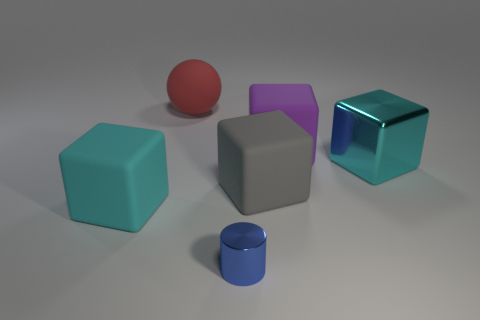Subtract all big cyan matte blocks. How many blocks are left? 3 Subtract all gray blocks. How many blocks are left? 3 Add 1 red rubber spheres. How many objects exist? 7 Subtract all cylinders. How many objects are left? 5 Add 5 blue things. How many blue things exist? 6 Subtract 0 blue balls. How many objects are left? 6 Subtract all yellow balls. Subtract all purple cylinders. How many balls are left? 1 Subtract all yellow cylinders. How many brown spheres are left? 0 Subtract all yellow matte balls. Subtract all large red rubber things. How many objects are left? 5 Add 6 large purple rubber things. How many large purple rubber things are left? 7 